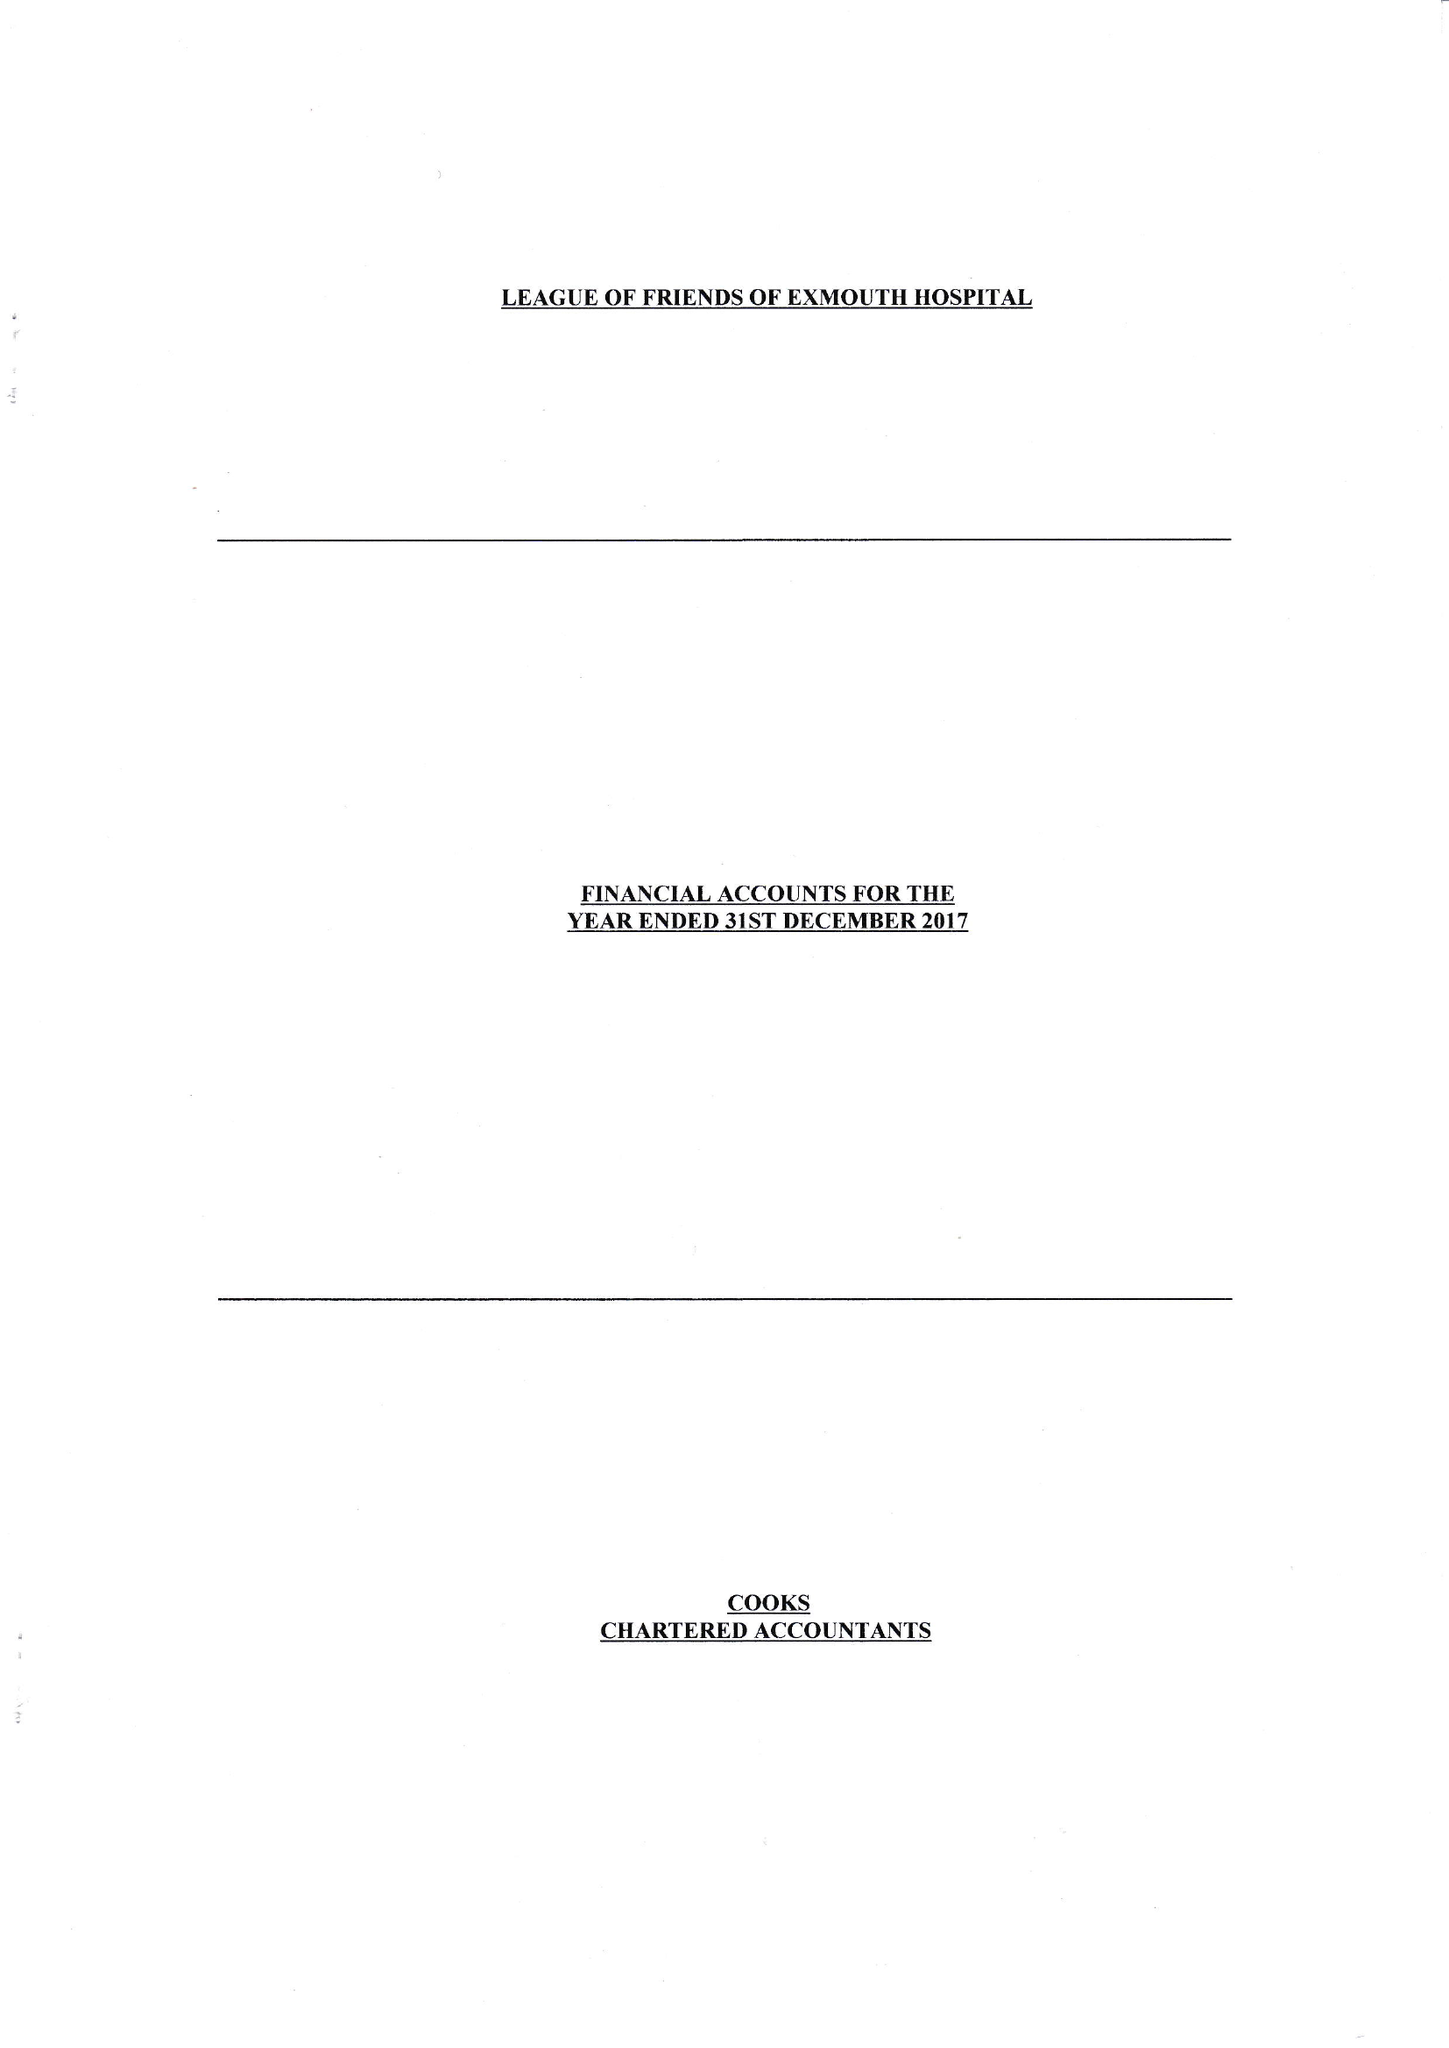What is the value for the charity_name?
Answer the question using a single word or phrase. The League Of Friends Of The Exmouth Hospital 